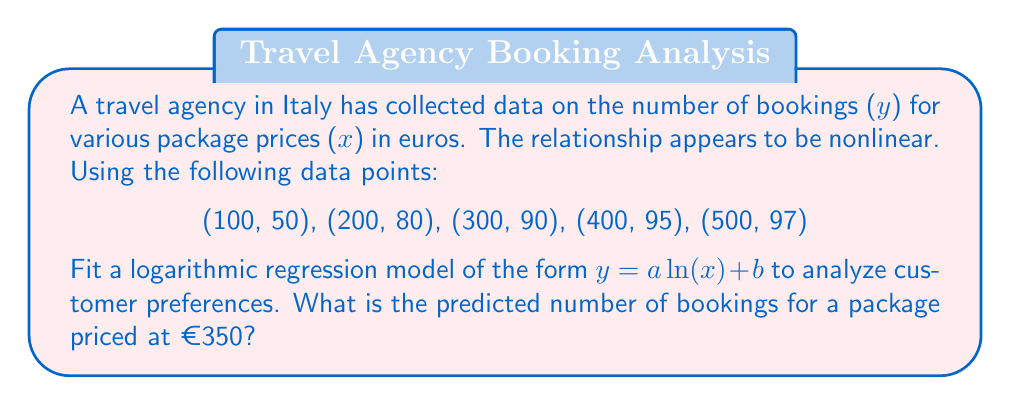Show me your answer to this math problem. To solve this problem, we'll follow these steps:

1) The logarithmic regression model is of the form $y = a \ln(x) + b$.

2) To find $a$ and $b$, we'll use the least squares method. We need to calculate:

   $a = \frac{n\sum(\ln(x)y) - \sum\ln(x)\sum y}{n\sum(\ln(x))^2 - (\sum\ln(x))^2}$

   $b = \bar{y} - a\overline{\ln(x)}$

3) Let's calculate the necessary sums:

   $\sum\ln(x) = \ln(100) + \ln(200) + \ln(300) + \ln(400) + \ln(500) = 28.034$
   $\sum y = 50 + 80 + 90 + 95 + 97 = 412$
   $\sum(\ln(x)y) = 4.605(50) + 5.298(80) + 5.704(90) + 5.991(95) + 6.215(97) = 2354.056$
   $\sum(\ln(x))^2 = 4.605^2 + 5.298^2 + 5.704^2 + 5.991^2 + 6.215^2 = 158.474$
   $n = 5$

4) Now we can calculate $a$:

   $a = \frac{5(2354.056) - 28.034(412)}{5(158.474) - 28.034^2} = 24.276$

5) To find $b$, we need $\bar{y}$ and $\overline{\ln(x)}$:

   $\bar{y} = 412/5 = 82.4$
   $\overline{\ln(x)} = 28.034/5 = 5.607$

   $b = 82.4 - 24.276(5.607) = -53.601$

6) Our regression model is: $y = 24.276\ln(x) - 53.601$

7) To predict the number of bookings for a package priced at €350:

   $y = 24.276\ln(350) - 53.601 = 93.186$
Answer: 93 bookings 